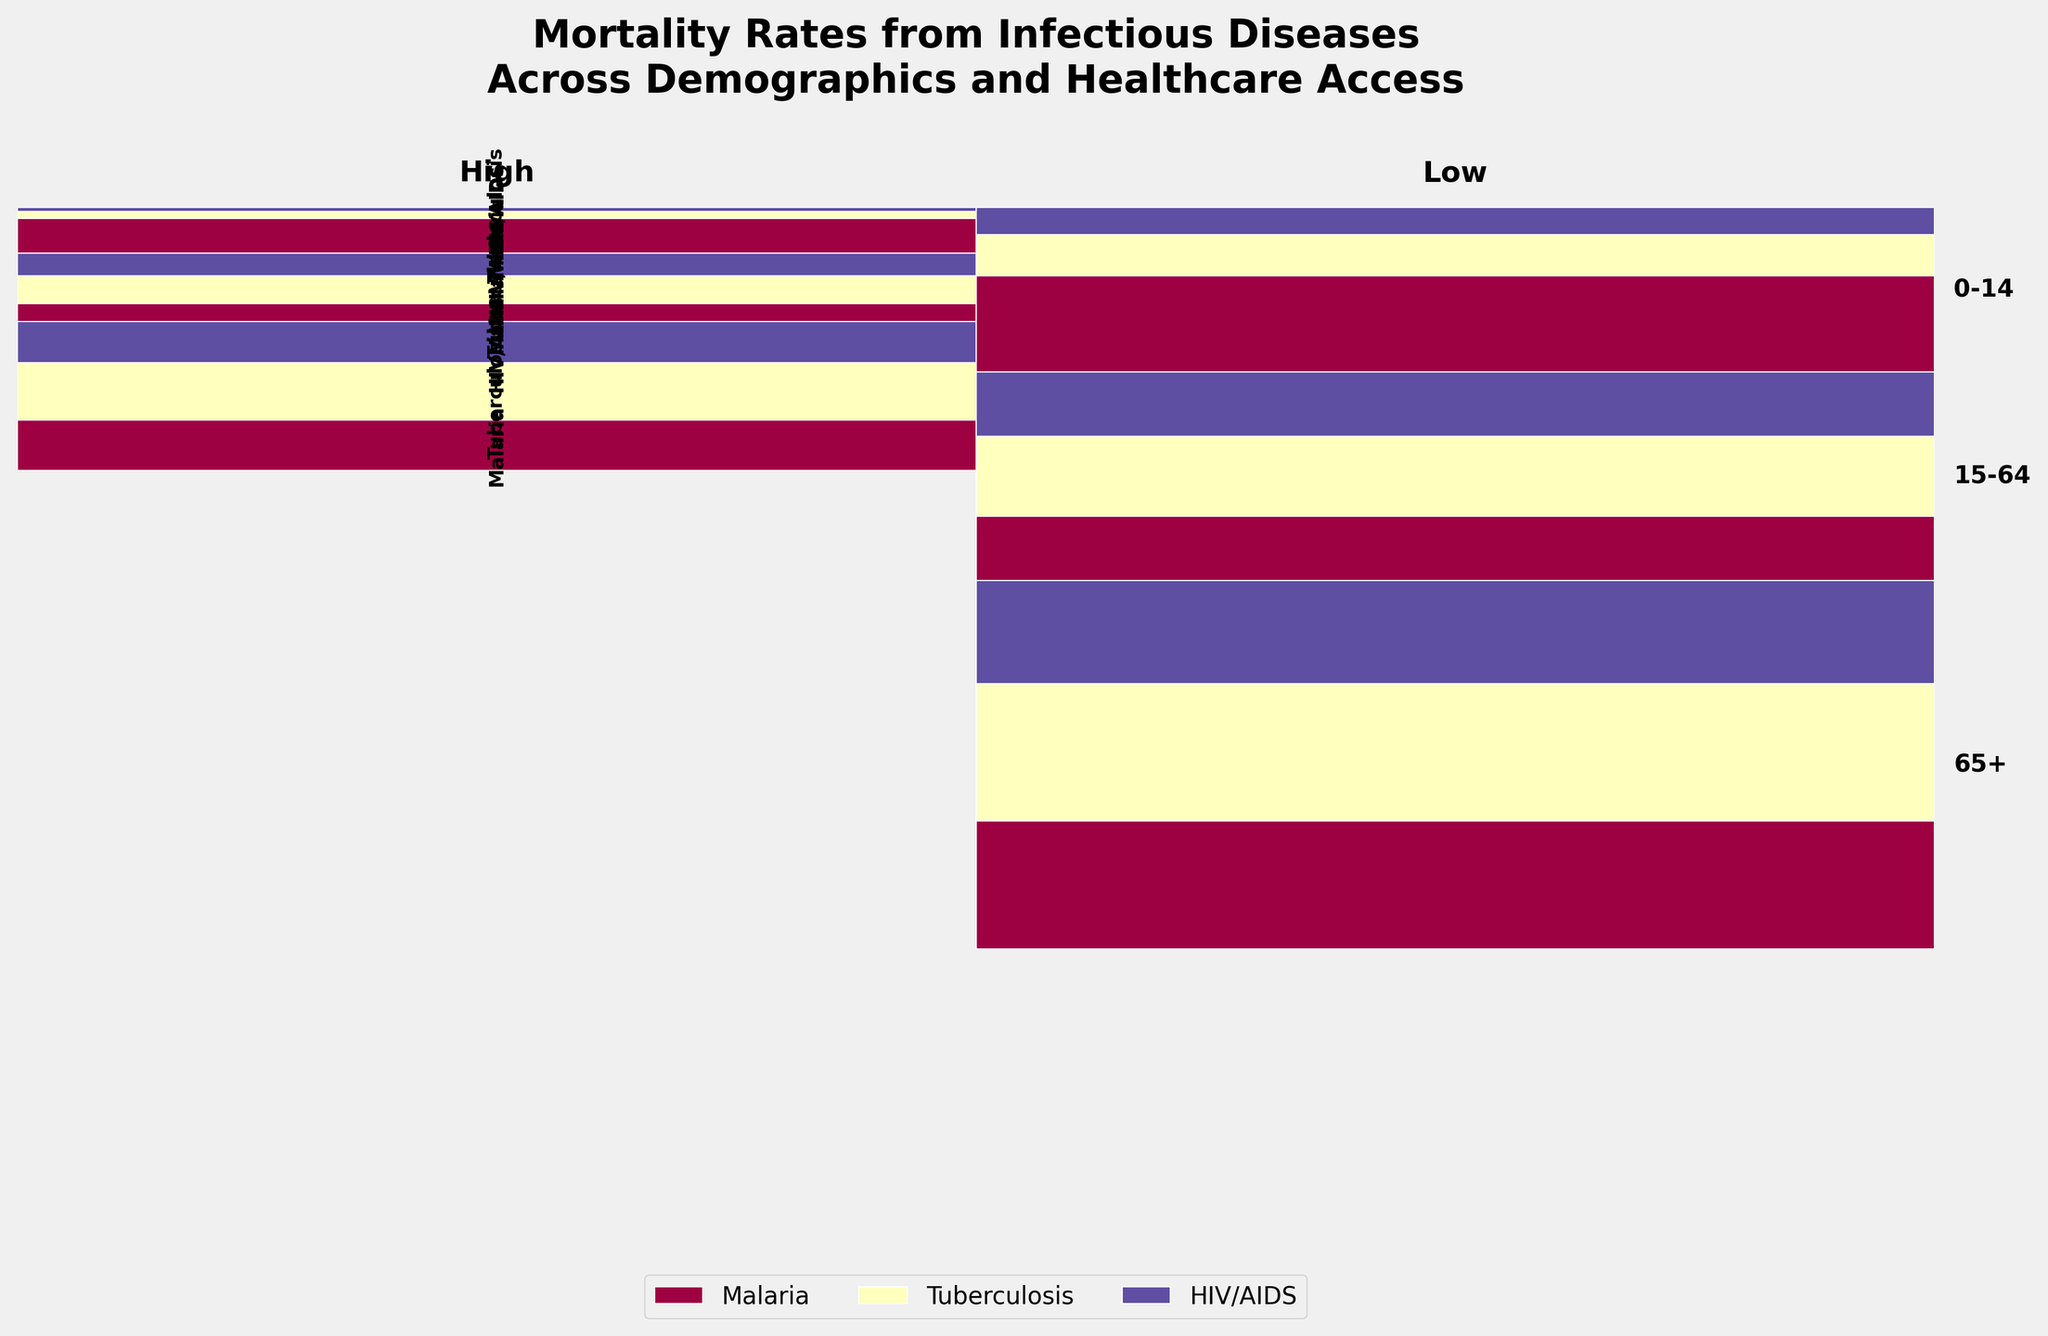What's the title of the figure? The title can be found at the top of the figure and describes the overall content depicted.
Answer: Mortality Rates from Infectious Diseases Across Demographics and Healthcare Access Which disease shows the lowest mortality rate for children aged 0-14 with high healthcare access? Locate the segment for children aged 0-14 under high healthcare access and compare the heights of the colored rectangles representing different diseases.
Answer: HIV/AIDS How does the mortality rate for Malaria in individuals aged 65+ compare between high and low healthcare access? Compare the height of the Malaria segments for the age group 65+ in both high and low healthcare access categories.
Answer: Malaria has a higher mortality rate with low healthcare access What is the general trend of mortality rates for Tuberculosis in different age groups under low healthcare access? Observe the heights of the segments representing Tuberculosis across age groups within the low healthcare access category.
Answer: Mortality rates increase with age What percentage of the total mortality rate does Malaria account for in the 15-64 age group under high healthcare access? Find the height of the Malaria segment for the 15-64 age group under high healthcare access and divide by the total height in that group. Multiply by 100.
Answer: Approximately 8% Which age group shows the greatest difference in HIV/AIDS mortality rates between high and low healthcare access? Compare the difference in the height of the HIV/AIDS segments across different age groups between the high and low healthcare access categories.
Answer: 15-64 age group In which demographic does tuberculosis mortality rate surpass malaria mortality rate under low healthcare access? Look for segments where Tuberculosis is taller than Malaria in the low healthcare access category. Verify the demographic characteristics (age group) where this comparison holds.
Answer: 0-14, 15-64, and 65+ age groups By observing the plot, what can we infer about the impact of healthcare access on infectious disease mortality rates for older adults (65+)? Compare the overall height of segments (representing the sum of the mortality rates for that age group) under high and low healthcare access for older adults (65+).
Answer: Lower healthcare access leads to significantly higher mortality rates Which disease has the largest difference in mortality rate between the youngest (0-14) and oldest (65+) age groups under low healthcare access? Compare the heights of each disease's segments for the youngest and oldest age groups under low healthcare access. Identify the disease with the largest height difference.
Answer: Malaria What visual feature indicates the distribution of mortality rates among different diseases within an age group and healthcare access level? Observe how the individual segments (heights of colored rectangles) within each age group and healthcare access category stack up to indicate the distribution.
Answer: The height of the colored rectangles 